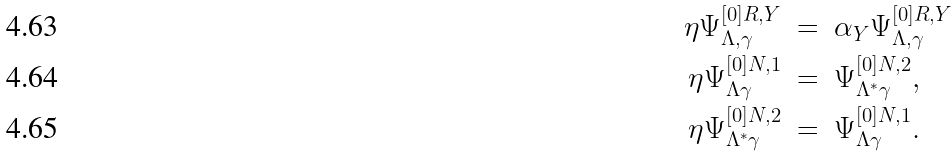<formula> <loc_0><loc_0><loc_500><loc_500>\eta \Psi ^ { [ 0 ] R , Y } _ { \Lambda , \gamma } \ & = \ \alpha _ { Y } \Psi ^ { [ 0 ] R , Y } _ { \Lambda , \gamma } \\ \eta \Psi ^ { [ 0 ] N , 1 } _ { \Lambda \gamma } \ & = \ \Psi ^ { [ 0 ] N , 2 } _ { \Lambda ^ { \ast } \gamma } , \\ \eta \Psi ^ { [ 0 ] N , 2 } _ { \Lambda ^ { \ast } \gamma } \ & = \ \Psi ^ { [ 0 ] N , 1 } _ { \Lambda \gamma } .</formula> 